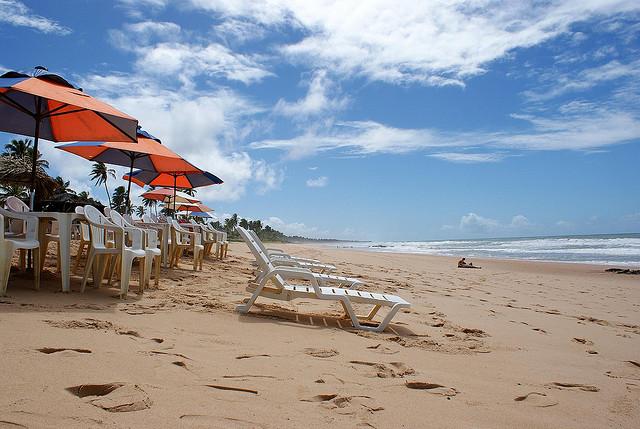What color are the chairs?
Concise answer only. White. Is anyone sitting in the chairs?
Write a very short answer. No. What number of grains of sand are on the beach?
Short answer required. Millions. 